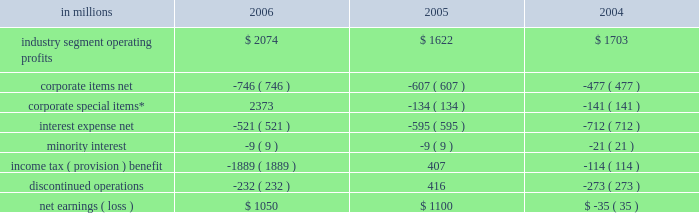Item 7 .
Management 2019s discussion and analysis of financial condition and results of operations executive summary international paper 2019s operating results in 2006 bene- fited from strong gains in pricing and sales volumes and lower operating costs .
Our average paper and packaging prices in 2006 increased faster than our costs for the first time in four years .
The improve- ment in sales volumes reflects increased uncoated papers , corrugated box , coated paperboard and european papers shipments , as well as improved revenues from our xpedx distribution business .
Our manufacturing operations also made solid cost reduction improvements .
Lower interest expense , reflecting debt repayments in 2005 and 2006 , was also a positive factor .
Together , these improvements more than offset the effects of continued high raw material and distribution costs , lower real estate sales , higher net corporate expenses and lower con- tributions from businesses and forestlands divested during 2006 .
Looking forward to 2007 , we expect seasonally higher sales volumes in the first quarter .
Average paper price realizations should continue to improve as we implement previously announced price increases in europe and brazil .
Input costs for energy , fiber and chemicals are expected to be mixed , although slightly higher in the first quarter .
Operating results will benefit from the recently completed international paper/sun paperboard joint ventures in china and the addition of the luiz anto- nio paper mill to our operations in brazil .
However , primarily as a result of lower real estate sales in the first quarter , we anticipate earnings from continuing operations will be somewhat lower than in the 2006 fourth quarter .
Significant steps were also taken in 2006 in the execution of the company 2019s transformation plan .
We completed the sales of our u.s .
And brazilian coated papers businesses and 5.6 million acres of u.s .
Forestlands , and announced definitive sale agreements for our kraft papers , beverage pack- aging and arizona chemical businesses and a majority of our wood products business , all expected to close during 2007 .
Through december 31 , 2006 , we have received approximately $ 9.7 billion of the estimated proceeds from divest- itures announced under this plan of approximately $ 11.3 billion , with the balance to be received as the remaining divestitures are completed in the first half of 2007 .
We have strengthened our balance sheet by reducing debt by $ 6.2 billion , and returned value to our shareholders by repurchasing 39.7 million shares of our common stock for approximately $ 1.4 billion .
We made a $ 1.0 billion voluntary contribution to our u.s .
Qualified pension fund .
We have identified selective reinvestment opportunities totaling approx- imately $ 2.0 billion , including opportunities in china , brazil and russia .
Finally , we remain focused on our three-year $ 1.2 billion target for non-price profit- ability improvements , with $ 330 million realized during 2006 .
While more remains to be done in 2007 , we have made substantial progress toward achiev- ing the objectives announced at the outset of the plan in july 2005 .
Results of operations industry segment operating profits are used by inter- national paper 2019s management to measure the earn- ings performance of its businesses .
Management believes that this measure allows a better under- standing of trends in costs , operating efficiencies , prices and volumes .
Industry segment operating profits are defined as earnings before taxes and minority interest , interest expense , corporate items and corporate special items .
Industry segment oper- ating profits are defined by the securities and exchange commission as a non-gaap financial measure , and are not gaap alternatives to net income or any other operating measure prescribed by accounting principles generally accepted in the united states .
International paper operates in six segments : print- ing papers , industrial packaging , consumer pack- aging , distribution , forest products and specialty businesses and other .
The table shows the components of net earnings ( loss ) for each of the last three years : in millions 2006 2005 2004 .
* corporate special items include gains on transformation plan forestland sales , goodwill impairment charges , restructuring and other charges , net losses on sales and impairments of businesses , insurance recoveries and reversals of reserves no longer required. .
What was the percentage change in industry segment operating profits from 2005 to 2006? 
Computations: ((2074 - 1622) / 1622)
Answer: 0.27867. 